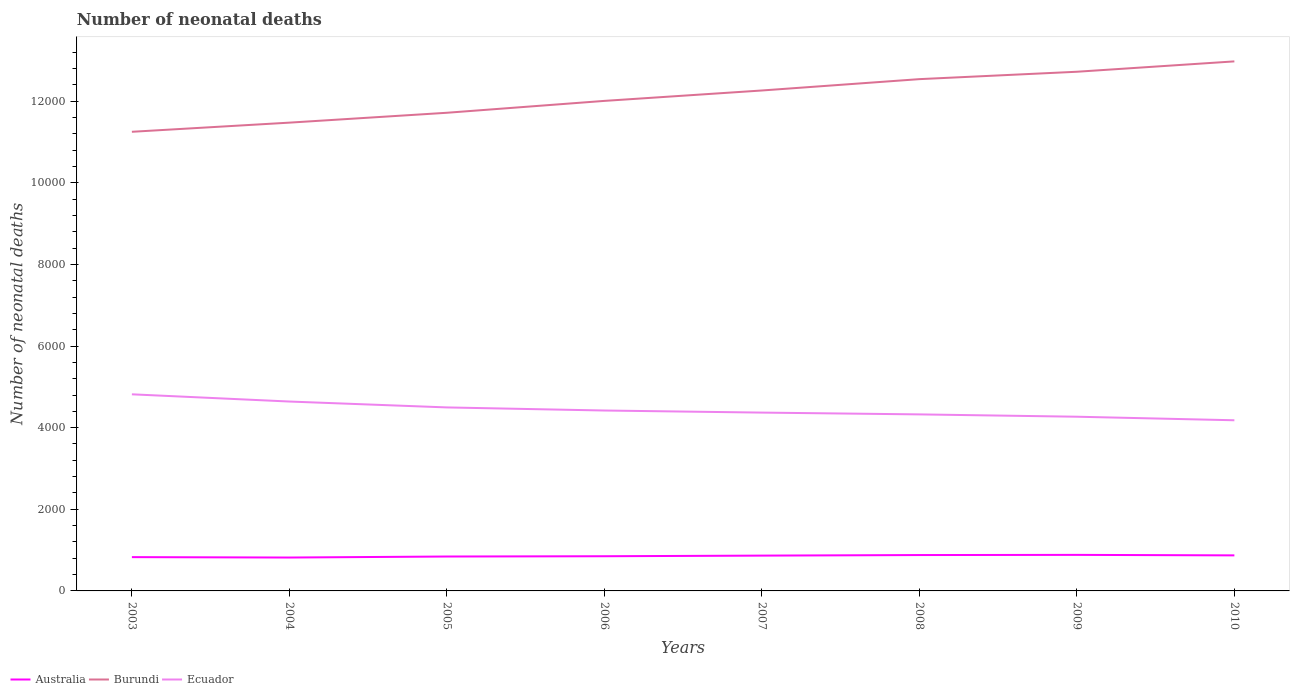How many different coloured lines are there?
Provide a short and direct response. 3. Across all years, what is the maximum number of neonatal deaths in in Ecuador?
Provide a succinct answer. 4181. In which year was the number of neonatal deaths in in Ecuador maximum?
Keep it short and to the point. 2010. What is the total number of neonatal deaths in in Ecuador in the graph?
Your answer should be very brief. 144. What is the difference between the highest and the second highest number of neonatal deaths in in Ecuador?
Give a very brief answer. 636. Does the graph contain any zero values?
Give a very brief answer. No. Does the graph contain grids?
Provide a succinct answer. No. Where does the legend appear in the graph?
Give a very brief answer. Bottom left. How many legend labels are there?
Give a very brief answer. 3. What is the title of the graph?
Ensure brevity in your answer.  Number of neonatal deaths. What is the label or title of the Y-axis?
Offer a terse response. Number of neonatal deaths. What is the Number of neonatal deaths of Australia in 2003?
Offer a very short reply. 828. What is the Number of neonatal deaths of Burundi in 2003?
Offer a very short reply. 1.12e+04. What is the Number of neonatal deaths of Ecuador in 2003?
Offer a terse response. 4817. What is the Number of neonatal deaths in Australia in 2004?
Your answer should be compact. 818. What is the Number of neonatal deaths in Burundi in 2004?
Your answer should be compact. 1.15e+04. What is the Number of neonatal deaths of Ecuador in 2004?
Provide a short and direct response. 4640. What is the Number of neonatal deaths in Australia in 2005?
Your answer should be very brief. 843. What is the Number of neonatal deaths in Burundi in 2005?
Provide a short and direct response. 1.17e+04. What is the Number of neonatal deaths in Ecuador in 2005?
Your response must be concise. 4496. What is the Number of neonatal deaths of Australia in 2006?
Offer a terse response. 850. What is the Number of neonatal deaths of Burundi in 2006?
Your response must be concise. 1.20e+04. What is the Number of neonatal deaths of Ecuador in 2006?
Offer a terse response. 4420. What is the Number of neonatal deaths of Australia in 2007?
Your answer should be very brief. 865. What is the Number of neonatal deaths of Burundi in 2007?
Provide a succinct answer. 1.23e+04. What is the Number of neonatal deaths in Ecuador in 2007?
Your answer should be very brief. 4369. What is the Number of neonatal deaths in Australia in 2008?
Offer a very short reply. 879. What is the Number of neonatal deaths of Burundi in 2008?
Offer a terse response. 1.25e+04. What is the Number of neonatal deaths of Ecuador in 2008?
Provide a succinct answer. 4325. What is the Number of neonatal deaths of Australia in 2009?
Offer a terse response. 883. What is the Number of neonatal deaths in Burundi in 2009?
Provide a succinct answer. 1.27e+04. What is the Number of neonatal deaths in Ecuador in 2009?
Your answer should be compact. 4268. What is the Number of neonatal deaths in Australia in 2010?
Provide a succinct answer. 871. What is the Number of neonatal deaths in Burundi in 2010?
Offer a very short reply. 1.30e+04. What is the Number of neonatal deaths in Ecuador in 2010?
Make the answer very short. 4181. Across all years, what is the maximum Number of neonatal deaths of Australia?
Ensure brevity in your answer.  883. Across all years, what is the maximum Number of neonatal deaths of Burundi?
Offer a terse response. 1.30e+04. Across all years, what is the maximum Number of neonatal deaths in Ecuador?
Give a very brief answer. 4817. Across all years, what is the minimum Number of neonatal deaths of Australia?
Offer a terse response. 818. Across all years, what is the minimum Number of neonatal deaths of Burundi?
Your answer should be very brief. 1.12e+04. Across all years, what is the minimum Number of neonatal deaths in Ecuador?
Your answer should be compact. 4181. What is the total Number of neonatal deaths in Australia in the graph?
Give a very brief answer. 6837. What is the total Number of neonatal deaths in Burundi in the graph?
Your response must be concise. 9.69e+04. What is the total Number of neonatal deaths in Ecuador in the graph?
Provide a short and direct response. 3.55e+04. What is the difference between the Number of neonatal deaths of Burundi in 2003 and that in 2004?
Your answer should be very brief. -224. What is the difference between the Number of neonatal deaths in Ecuador in 2003 and that in 2004?
Keep it short and to the point. 177. What is the difference between the Number of neonatal deaths of Burundi in 2003 and that in 2005?
Give a very brief answer. -466. What is the difference between the Number of neonatal deaths of Ecuador in 2003 and that in 2005?
Offer a very short reply. 321. What is the difference between the Number of neonatal deaths of Australia in 2003 and that in 2006?
Offer a very short reply. -22. What is the difference between the Number of neonatal deaths of Burundi in 2003 and that in 2006?
Provide a short and direct response. -757. What is the difference between the Number of neonatal deaths of Ecuador in 2003 and that in 2006?
Your answer should be very brief. 397. What is the difference between the Number of neonatal deaths of Australia in 2003 and that in 2007?
Make the answer very short. -37. What is the difference between the Number of neonatal deaths of Burundi in 2003 and that in 2007?
Ensure brevity in your answer.  -1012. What is the difference between the Number of neonatal deaths in Ecuador in 2003 and that in 2007?
Your answer should be compact. 448. What is the difference between the Number of neonatal deaths in Australia in 2003 and that in 2008?
Make the answer very short. -51. What is the difference between the Number of neonatal deaths in Burundi in 2003 and that in 2008?
Provide a succinct answer. -1290. What is the difference between the Number of neonatal deaths in Ecuador in 2003 and that in 2008?
Give a very brief answer. 492. What is the difference between the Number of neonatal deaths in Australia in 2003 and that in 2009?
Make the answer very short. -55. What is the difference between the Number of neonatal deaths in Burundi in 2003 and that in 2009?
Provide a succinct answer. -1471. What is the difference between the Number of neonatal deaths of Ecuador in 2003 and that in 2009?
Your answer should be very brief. 549. What is the difference between the Number of neonatal deaths of Australia in 2003 and that in 2010?
Your response must be concise. -43. What is the difference between the Number of neonatal deaths in Burundi in 2003 and that in 2010?
Make the answer very short. -1725. What is the difference between the Number of neonatal deaths in Ecuador in 2003 and that in 2010?
Ensure brevity in your answer.  636. What is the difference between the Number of neonatal deaths in Australia in 2004 and that in 2005?
Keep it short and to the point. -25. What is the difference between the Number of neonatal deaths in Burundi in 2004 and that in 2005?
Make the answer very short. -242. What is the difference between the Number of neonatal deaths of Ecuador in 2004 and that in 2005?
Provide a succinct answer. 144. What is the difference between the Number of neonatal deaths of Australia in 2004 and that in 2006?
Keep it short and to the point. -32. What is the difference between the Number of neonatal deaths in Burundi in 2004 and that in 2006?
Offer a terse response. -533. What is the difference between the Number of neonatal deaths in Ecuador in 2004 and that in 2006?
Keep it short and to the point. 220. What is the difference between the Number of neonatal deaths in Australia in 2004 and that in 2007?
Provide a short and direct response. -47. What is the difference between the Number of neonatal deaths of Burundi in 2004 and that in 2007?
Ensure brevity in your answer.  -788. What is the difference between the Number of neonatal deaths of Ecuador in 2004 and that in 2007?
Provide a short and direct response. 271. What is the difference between the Number of neonatal deaths in Australia in 2004 and that in 2008?
Ensure brevity in your answer.  -61. What is the difference between the Number of neonatal deaths in Burundi in 2004 and that in 2008?
Ensure brevity in your answer.  -1066. What is the difference between the Number of neonatal deaths in Ecuador in 2004 and that in 2008?
Your answer should be compact. 315. What is the difference between the Number of neonatal deaths in Australia in 2004 and that in 2009?
Ensure brevity in your answer.  -65. What is the difference between the Number of neonatal deaths of Burundi in 2004 and that in 2009?
Make the answer very short. -1247. What is the difference between the Number of neonatal deaths of Ecuador in 2004 and that in 2009?
Your answer should be compact. 372. What is the difference between the Number of neonatal deaths in Australia in 2004 and that in 2010?
Your answer should be compact. -53. What is the difference between the Number of neonatal deaths of Burundi in 2004 and that in 2010?
Ensure brevity in your answer.  -1501. What is the difference between the Number of neonatal deaths in Ecuador in 2004 and that in 2010?
Your answer should be very brief. 459. What is the difference between the Number of neonatal deaths in Australia in 2005 and that in 2006?
Your answer should be compact. -7. What is the difference between the Number of neonatal deaths in Burundi in 2005 and that in 2006?
Offer a terse response. -291. What is the difference between the Number of neonatal deaths of Burundi in 2005 and that in 2007?
Your answer should be compact. -546. What is the difference between the Number of neonatal deaths in Ecuador in 2005 and that in 2007?
Your answer should be very brief. 127. What is the difference between the Number of neonatal deaths of Australia in 2005 and that in 2008?
Your answer should be compact. -36. What is the difference between the Number of neonatal deaths of Burundi in 2005 and that in 2008?
Provide a short and direct response. -824. What is the difference between the Number of neonatal deaths in Ecuador in 2005 and that in 2008?
Provide a short and direct response. 171. What is the difference between the Number of neonatal deaths of Burundi in 2005 and that in 2009?
Give a very brief answer. -1005. What is the difference between the Number of neonatal deaths in Ecuador in 2005 and that in 2009?
Make the answer very short. 228. What is the difference between the Number of neonatal deaths of Australia in 2005 and that in 2010?
Offer a very short reply. -28. What is the difference between the Number of neonatal deaths in Burundi in 2005 and that in 2010?
Offer a very short reply. -1259. What is the difference between the Number of neonatal deaths of Ecuador in 2005 and that in 2010?
Your answer should be compact. 315. What is the difference between the Number of neonatal deaths of Australia in 2006 and that in 2007?
Make the answer very short. -15. What is the difference between the Number of neonatal deaths of Burundi in 2006 and that in 2007?
Your response must be concise. -255. What is the difference between the Number of neonatal deaths of Australia in 2006 and that in 2008?
Provide a short and direct response. -29. What is the difference between the Number of neonatal deaths in Burundi in 2006 and that in 2008?
Offer a very short reply. -533. What is the difference between the Number of neonatal deaths in Australia in 2006 and that in 2009?
Offer a terse response. -33. What is the difference between the Number of neonatal deaths in Burundi in 2006 and that in 2009?
Your answer should be compact. -714. What is the difference between the Number of neonatal deaths in Ecuador in 2006 and that in 2009?
Offer a terse response. 152. What is the difference between the Number of neonatal deaths of Australia in 2006 and that in 2010?
Your answer should be compact. -21. What is the difference between the Number of neonatal deaths in Burundi in 2006 and that in 2010?
Your response must be concise. -968. What is the difference between the Number of neonatal deaths of Ecuador in 2006 and that in 2010?
Make the answer very short. 239. What is the difference between the Number of neonatal deaths of Australia in 2007 and that in 2008?
Your answer should be compact. -14. What is the difference between the Number of neonatal deaths of Burundi in 2007 and that in 2008?
Your answer should be compact. -278. What is the difference between the Number of neonatal deaths in Ecuador in 2007 and that in 2008?
Your answer should be very brief. 44. What is the difference between the Number of neonatal deaths of Australia in 2007 and that in 2009?
Give a very brief answer. -18. What is the difference between the Number of neonatal deaths of Burundi in 2007 and that in 2009?
Keep it short and to the point. -459. What is the difference between the Number of neonatal deaths in Ecuador in 2007 and that in 2009?
Make the answer very short. 101. What is the difference between the Number of neonatal deaths in Australia in 2007 and that in 2010?
Provide a short and direct response. -6. What is the difference between the Number of neonatal deaths of Burundi in 2007 and that in 2010?
Your answer should be compact. -713. What is the difference between the Number of neonatal deaths of Ecuador in 2007 and that in 2010?
Your response must be concise. 188. What is the difference between the Number of neonatal deaths of Australia in 2008 and that in 2009?
Offer a very short reply. -4. What is the difference between the Number of neonatal deaths of Burundi in 2008 and that in 2009?
Ensure brevity in your answer.  -181. What is the difference between the Number of neonatal deaths in Ecuador in 2008 and that in 2009?
Ensure brevity in your answer.  57. What is the difference between the Number of neonatal deaths of Australia in 2008 and that in 2010?
Give a very brief answer. 8. What is the difference between the Number of neonatal deaths of Burundi in 2008 and that in 2010?
Keep it short and to the point. -435. What is the difference between the Number of neonatal deaths of Ecuador in 2008 and that in 2010?
Give a very brief answer. 144. What is the difference between the Number of neonatal deaths of Australia in 2009 and that in 2010?
Offer a terse response. 12. What is the difference between the Number of neonatal deaths in Burundi in 2009 and that in 2010?
Make the answer very short. -254. What is the difference between the Number of neonatal deaths in Ecuador in 2009 and that in 2010?
Ensure brevity in your answer.  87. What is the difference between the Number of neonatal deaths of Australia in 2003 and the Number of neonatal deaths of Burundi in 2004?
Give a very brief answer. -1.06e+04. What is the difference between the Number of neonatal deaths in Australia in 2003 and the Number of neonatal deaths in Ecuador in 2004?
Keep it short and to the point. -3812. What is the difference between the Number of neonatal deaths of Burundi in 2003 and the Number of neonatal deaths of Ecuador in 2004?
Keep it short and to the point. 6609. What is the difference between the Number of neonatal deaths in Australia in 2003 and the Number of neonatal deaths in Burundi in 2005?
Keep it short and to the point. -1.09e+04. What is the difference between the Number of neonatal deaths in Australia in 2003 and the Number of neonatal deaths in Ecuador in 2005?
Your response must be concise. -3668. What is the difference between the Number of neonatal deaths in Burundi in 2003 and the Number of neonatal deaths in Ecuador in 2005?
Keep it short and to the point. 6753. What is the difference between the Number of neonatal deaths in Australia in 2003 and the Number of neonatal deaths in Burundi in 2006?
Make the answer very short. -1.12e+04. What is the difference between the Number of neonatal deaths in Australia in 2003 and the Number of neonatal deaths in Ecuador in 2006?
Your response must be concise. -3592. What is the difference between the Number of neonatal deaths of Burundi in 2003 and the Number of neonatal deaths of Ecuador in 2006?
Your response must be concise. 6829. What is the difference between the Number of neonatal deaths in Australia in 2003 and the Number of neonatal deaths in Burundi in 2007?
Provide a succinct answer. -1.14e+04. What is the difference between the Number of neonatal deaths in Australia in 2003 and the Number of neonatal deaths in Ecuador in 2007?
Your answer should be very brief. -3541. What is the difference between the Number of neonatal deaths in Burundi in 2003 and the Number of neonatal deaths in Ecuador in 2007?
Make the answer very short. 6880. What is the difference between the Number of neonatal deaths in Australia in 2003 and the Number of neonatal deaths in Burundi in 2008?
Offer a terse response. -1.17e+04. What is the difference between the Number of neonatal deaths in Australia in 2003 and the Number of neonatal deaths in Ecuador in 2008?
Keep it short and to the point. -3497. What is the difference between the Number of neonatal deaths in Burundi in 2003 and the Number of neonatal deaths in Ecuador in 2008?
Offer a very short reply. 6924. What is the difference between the Number of neonatal deaths in Australia in 2003 and the Number of neonatal deaths in Burundi in 2009?
Offer a very short reply. -1.19e+04. What is the difference between the Number of neonatal deaths in Australia in 2003 and the Number of neonatal deaths in Ecuador in 2009?
Offer a very short reply. -3440. What is the difference between the Number of neonatal deaths in Burundi in 2003 and the Number of neonatal deaths in Ecuador in 2009?
Provide a short and direct response. 6981. What is the difference between the Number of neonatal deaths of Australia in 2003 and the Number of neonatal deaths of Burundi in 2010?
Your answer should be very brief. -1.21e+04. What is the difference between the Number of neonatal deaths in Australia in 2003 and the Number of neonatal deaths in Ecuador in 2010?
Provide a succinct answer. -3353. What is the difference between the Number of neonatal deaths in Burundi in 2003 and the Number of neonatal deaths in Ecuador in 2010?
Your response must be concise. 7068. What is the difference between the Number of neonatal deaths of Australia in 2004 and the Number of neonatal deaths of Burundi in 2005?
Make the answer very short. -1.09e+04. What is the difference between the Number of neonatal deaths of Australia in 2004 and the Number of neonatal deaths of Ecuador in 2005?
Provide a succinct answer. -3678. What is the difference between the Number of neonatal deaths of Burundi in 2004 and the Number of neonatal deaths of Ecuador in 2005?
Your response must be concise. 6977. What is the difference between the Number of neonatal deaths of Australia in 2004 and the Number of neonatal deaths of Burundi in 2006?
Your response must be concise. -1.12e+04. What is the difference between the Number of neonatal deaths of Australia in 2004 and the Number of neonatal deaths of Ecuador in 2006?
Keep it short and to the point. -3602. What is the difference between the Number of neonatal deaths in Burundi in 2004 and the Number of neonatal deaths in Ecuador in 2006?
Provide a short and direct response. 7053. What is the difference between the Number of neonatal deaths in Australia in 2004 and the Number of neonatal deaths in Burundi in 2007?
Ensure brevity in your answer.  -1.14e+04. What is the difference between the Number of neonatal deaths of Australia in 2004 and the Number of neonatal deaths of Ecuador in 2007?
Make the answer very short. -3551. What is the difference between the Number of neonatal deaths in Burundi in 2004 and the Number of neonatal deaths in Ecuador in 2007?
Your answer should be compact. 7104. What is the difference between the Number of neonatal deaths in Australia in 2004 and the Number of neonatal deaths in Burundi in 2008?
Keep it short and to the point. -1.17e+04. What is the difference between the Number of neonatal deaths in Australia in 2004 and the Number of neonatal deaths in Ecuador in 2008?
Your response must be concise. -3507. What is the difference between the Number of neonatal deaths of Burundi in 2004 and the Number of neonatal deaths of Ecuador in 2008?
Your response must be concise. 7148. What is the difference between the Number of neonatal deaths of Australia in 2004 and the Number of neonatal deaths of Burundi in 2009?
Ensure brevity in your answer.  -1.19e+04. What is the difference between the Number of neonatal deaths of Australia in 2004 and the Number of neonatal deaths of Ecuador in 2009?
Give a very brief answer. -3450. What is the difference between the Number of neonatal deaths of Burundi in 2004 and the Number of neonatal deaths of Ecuador in 2009?
Your answer should be very brief. 7205. What is the difference between the Number of neonatal deaths of Australia in 2004 and the Number of neonatal deaths of Burundi in 2010?
Make the answer very short. -1.22e+04. What is the difference between the Number of neonatal deaths in Australia in 2004 and the Number of neonatal deaths in Ecuador in 2010?
Your answer should be very brief. -3363. What is the difference between the Number of neonatal deaths in Burundi in 2004 and the Number of neonatal deaths in Ecuador in 2010?
Ensure brevity in your answer.  7292. What is the difference between the Number of neonatal deaths of Australia in 2005 and the Number of neonatal deaths of Burundi in 2006?
Offer a terse response. -1.12e+04. What is the difference between the Number of neonatal deaths of Australia in 2005 and the Number of neonatal deaths of Ecuador in 2006?
Give a very brief answer. -3577. What is the difference between the Number of neonatal deaths of Burundi in 2005 and the Number of neonatal deaths of Ecuador in 2006?
Your response must be concise. 7295. What is the difference between the Number of neonatal deaths of Australia in 2005 and the Number of neonatal deaths of Burundi in 2007?
Give a very brief answer. -1.14e+04. What is the difference between the Number of neonatal deaths of Australia in 2005 and the Number of neonatal deaths of Ecuador in 2007?
Keep it short and to the point. -3526. What is the difference between the Number of neonatal deaths of Burundi in 2005 and the Number of neonatal deaths of Ecuador in 2007?
Your response must be concise. 7346. What is the difference between the Number of neonatal deaths of Australia in 2005 and the Number of neonatal deaths of Burundi in 2008?
Make the answer very short. -1.17e+04. What is the difference between the Number of neonatal deaths of Australia in 2005 and the Number of neonatal deaths of Ecuador in 2008?
Offer a very short reply. -3482. What is the difference between the Number of neonatal deaths in Burundi in 2005 and the Number of neonatal deaths in Ecuador in 2008?
Keep it short and to the point. 7390. What is the difference between the Number of neonatal deaths in Australia in 2005 and the Number of neonatal deaths in Burundi in 2009?
Ensure brevity in your answer.  -1.19e+04. What is the difference between the Number of neonatal deaths in Australia in 2005 and the Number of neonatal deaths in Ecuador in 2009?
Your answer should be very brief. -3425. What is the difference between the Number of neonatal deaths in Burundi in 2005 and the Number of neonatal deaths in Ecuador in 2009?
Keep it short and to the point. 7447. What is the difference between the Number of neonatal deaths in Australia in 2005 and the Number of neonatal deaths in Burundi in 2010?
Provide a short and direct response. -1.21e+04. What is the difference between the Number of neonatal deaths in Australia in 2005 and the Number of neonatal deaths in Ecuador in 2010?
Provide a succinct answer. -3338. What is the difference between the Number of neonatal deaths of Burundi in 2005 and the Number of neonatal deaths of Ecuador in 2010?
Give a very brief answer. 7534. What is the difference between the Number of neonatal deaths of Australia in 2006 and the Number of neonatal deaths of Burundi in 2007?
Your answer should be very brief. -1.14e+04. What is the difference between the Number of neonatal deaths of Australia in 2006 and the Number of neonatal deaths of Ecuador in 2007?
Your answer should be compact. -3519. What is the difference between the Number of neonatal deaths of Burundi in 2006 and the Number of neonatal deaths of Ecuador in 2007?
Keep it short and to the point. 7637. What is the difference between the Number of neonatal deaths in Australia in 2006 and the Number of neonatal deaths in Burundi in 2008?
Offer a very short reply. -1.17e+04. What is the difference between the Number of neonatal deaths in Australia in 2006 and the Number of neonatal deaths in Ecuador in 2008?
Offer a terse response. -3475. What is the difference between the Number of neonatal deaths in Burundi in 2006 and the Number of neonatal deaths in Ecuador in 2008?
Offer a very short reply. 7681. What is the difference between the Number of neonatal deaths of Australia in 2006 and the Number of neonatal deaths of Burundi in 2009?
Offer a very short reply. -1.19e+04. What is the difference between the Number of neonatal deaths in Australia in 2006 and the Number of neonatal deaths in Ecuador in 2009?
Ensure brevity in your answer.  -3418. What is the difference between the Number of neonatal deaths in Burundi in 2006 and the Number of neonatal deaths in Ecuador in 2009?
Your answer should be very brief. 7738. What is the difference between the Number of neonatal deaths in Australia in 2006 and the Number of neonatal deaths in Burundi in 2010?
Offer a terse response. -1.21e+04. What is the difference between the Number of neonatal deaths of Australia in 2006 and the Number of neonatal deaths of Ecuador in 2010?
Provide a succinct answer. -3331. What is the difference between the Number of neonatal deaths of Burundi in 2006 and the Number of neonatal deaths of Ecuador in 2010?
Provide a succinct answer. 7825. What is the difference between the Number of neonatal deaths of Australia in 2007 and the Number of neonatal deaths of Burundi in 2008?
Make the answer very short. -1.17e+04. What is the difference between the Number of neonatal deaths of Australia in 2007 and the Number of neonatal deaths of Ecuador in 2008?
Keep it short and to the point. -3460. What is the difference between the Number of neonatal deaths in Burundi in 2007 and the Number of neonatal deaths in Ecuador in 2008?
Give a very brief answer. 7936. What is the difference between the Number of neonatal deaths in Australia in 2007 and the Number of neonatal deaths in Burundi in 2009?
Your answer should be compact. -1.19e+04. What is the difference between the Number of neonatal deaths of Australia in 2007 and the Number of neonatal deaths of Ecuador in 2009?
Provide a succinct answer. -3403. What is the difference between the Number of neonatal deaths of Burundi in 2007 and the Number of neonatal deaths of Ecuador in 2009?
Make the answer very short. 7993. What is the difference between the Number of neonatal deaths of Australia in 2007 and the Number of neonatal deaths of Burundi in 2010?
Make the answer very short. -1.21e+04. What is the difference between the Number of neonatal deaths of Australia in 2007 and the Number of neonatal deaths of Ecuador in 2010?
Make the answer very short. -3316. What is the difference between the Number of neonatal deaths in Burundi in 2007 and the Number of neonatal deaths in Ecuador in 2010?
Ensure brevity in your answer.  8080. What is the difference between the Number of neonatal deaths of Australia in 2008 and the Number of neonatal deaths of Burundi in 2009?
Give a very brief answer. -1.18e+04. What is the difference between the Number of neonatal deaths in Australia in 2008 and the Number of neonatal deaths in Ecuador in 2009?
Offer a very short reply. -3389. What is the difference between the Number of neonatal deaths of Burundi in 2008 and the Number of neonatal deaths of Ecuador in 2009?
Provide a succinct answer. 8271. What is the difference between the Number of neonatal deaths in Australia in 2008 and the Number of neonatal deaths in Burundi in 2010?
Your response must be concise. -1.21e+04. What is the difference between the Number of neonatal deaths of Australia in 2008 and the Number of neonatal deaths of Ecuador in 2010?
Your answer should be very brief. -3302. What is the difference between the Number of neonatal deaths of Burundi in 2008 and the Number of neonatal deaths of Ecuador in 2010?
Keep it short and to the point. 8358. What is the difference between the Number of neonatal deaths of Australia in 2009 and the Number of neonatal deaths of Burundi in 2010?
Keep it short and to the point. -1.21e+04. What is the difference between the Number of neonatal deaths in Australia in 2009 and the Number of neonatal deaths in Ecuador in 2010?
Your answer should be compact. -3298. What is the difference between the Number of neonatal deaths in Burundi in 2009 and the Number of neonatal deaths in Ecuador in 2010?
Keep it short and to the point. 8539. What is the average Number of neonatal deaths of Australia per year?
Provide a succinct answer. 854.62. What is the average Number of neonatal deaths of Burundi per year?
Your response must be concise. 1.21e+04. What is the average Number of neonatal deaths of Ecuador per year?
Offer a very short reply. 4439.5. In the year 2003, what is the difference between the Number of neonatal deaths in Australia and Number of neonatal deaths in Burundi?
Give a very brief answer. -1.04e+04. In the year 2003, what is the difference between the Number of neonatal deaths in Australia and Number of neonatal deaths in Ecuador?
Your answer should be compact. -3989. In the year 2003, what is the difference between the Number of neonatal deaths in Burundi and Number of neonatal deaths in Ecuador?
Provide a succinct answer. 6432. In the year 2004, what is the difference between the Number of neonatal deaths in Australia and Number of neonatal deaths in Burundi?
Your response must be concise. -1.07e+04. In the year 2004, what is the difference between the Number of neonatal deaths in Australia and Number of neonatal deaths in Ecuador?
Ensure brevity in your answer.  -3822. In the year 2004, what is the difference between the Number of neonatal deaths in Burundi and Number of neonatal deaths in Ecuador?
Offer a terse response. 6833. In the year 2005, what is the difference between the Number of neonatal deaths in Australia and Number of neonatal deaths in Burundi?
Your response must be concise. -1.09e+04. In the year 2005, what is the difference between the Number of neonatal deaths in Australia and Number of neonatal deaths in Ecuador?
Your response must be concise. -3653. In the year 2005, what is the difference between the Number of neonatal deaths of Burundi and Number of neonatal deaths of Ecuador?
Offer a very short reply. 7219. In the year 2006, what is the difference between the Number of neonatal deaths of Australia and Number of neonatal deaths of Burundi?
Provide a succinct answer. -1.12e+04. In the year 2006, what is the difference between the Number of neonatal deaths in Australia and Number of neonatal deaths in Ecuador?
Your response must be concise. -3570. In the year 2006, what is the difference between the Number of neonatal deaths of Burundi and Number of neonatal deaths of Ecuador?
Give a very brief answer. 7586. In the year 2007, what is the difference between the Number of neonatal deaths of Australia and Number of neonatal deaths of Burundi?
Keep it short and to the point. -1.14e+04. In the year 2007, what is the difference between the Number of neonatal deaths in Australia and Number of neonatal deaths in Ecuador?
Your response must be concise. -3504. In the year 2007, what is the difference between the Number of neonatal deaths of Burundi and Number of neonatal deaths of Ecuador?
Offer a very short reply. 7892. In the year 2008, what is the difference between the Number of neonatal deaths in Australia and Number of neonatal deaths in Burundi?
Provide a short and direct response. -1.17e+04. In the year 2008, what is the difference between the Number of neonatal deaths in Australia and Number of neonatal deaths in Ecuador?
Your answer should be very brief. -3446. In the year 2008, what is the difference between the Number of neonatal deaths of Burundi and Number of neonatal deaths of Ecuador?
Your answer should be very brief. 8214. In the year 2009, what is the difference between the Number of neonatal deaths in Australia and Number of neonatal deaths in Burundi?
Give a very brief answer. -1.18e+04. In the year 2009, what is the difference between the Number of neonatal deaths of Australia and Number of neonatal deaths of Ecuador?
Your answer should be compact. -3385. In the year 2009, what is the difference between the Number of neonatal deaths in Burundi and Number of neonatal deaths in Ecuador?
Ensure brevity in your answer.  8452. In the year 2010, what is the difference between the Number of neonatal deaths of Australia and Number of neonatal deaths of Burundi?
Your answer should be very brief. -1.21e+04. In the year 2010, what is the difference between the Number of neonatal deaths of Australia and Number of neonatal deaths of Ecuador?
Ensure brevity in your answer.  -3310. In the year 2010, what is the difference between the Number of neonatal deaths in Burundi and Number of neonatal deaths in Ecuador?
Ensure brevity in your answer.  8793. What is the ratio of the Number of neonatal deaths of Australia in 2003 to that in 2004?
Keep it short and to the point. 1.01. What is the ratio of the Number of neonatal deaths in Burundi in 2003 to that in 2004?
Your answer should be compact. 0.98. What is the ratio of the Number of neonatal deaths of Ecuador in 2003 to that in 2004?
Offer a terse response. 1.04. What is the ratio of the Number of neonatal deaths of Australia in 2003 to that in 2005?
Your response must be concise. 0.98. What is the ratio of the Number of neonatal deaths of Burundi in 2003 to that in 2005?
Provide a succinct answer. 0.96. What is the ratio of the Number of neonatal deaths in Ecuador in 2003 to that in 2005?
Offer a very short reply. 1.07. What is the ratio of the Number of neonatal deaths in Australia in 2003 to that in 2006?
Make the answer very short. 0.97. What is the ratio of the Number of neonatal deaths in Burundi in 2003 to that in 2006?
Provide a short and direct response. 0.94. What is the ratio of the Number of neonatal deaths of Ecuador in 2003 to that in 2006?
Your answer should be compact. 1.09. What is the ratio of the Number of neonatal deaths in Australia in 2003 to that in 2007?
Provide a short and direct response. 0.96. What is the ratio of the Number of neonatal deaths in Burundi in 2003 to that in 2007?
Your answer should be compact. 0.92. What is the ratio of the Number of neonatal deaths in Ecuador in 2003 to that in 2007?
Ensure brevity in your answer.  1.1. What is the ratio of the Number of neonatal deaths of Australia in 2003 to that in 2008?
Ensure brevity in your answer.  0.94. What is the ratio of the Number of neonatal deaths in Burundi in 2003 to that in 2008?
Offer a terse response. 0.9. What is the ratio of the Number of neonatal deaths of Ecuador in 2003 to that in 2008?
Make the answer very short. 1.11. What is the ratio of the Number of neonatal deaths of Australia in 2003 to that in 2009?
Make the answer very short. 0.94. What is the ratio of the Number of neonatal deaths of Burundi in 2003 to that in 2009?
Offer a very short reply. 0.88. What is the ratio of the Number of neonatal deaths of Ecuador in 2003 to that in 2009?
Ensure brevity in your answer.  1.13. What is the ratio of the Number of neonatal deaths in Australia in 2003 to that in 2010?
Your answer should be compact. 0.95. What is the ratio of the Number of neonatal deaths of Burundi in 2003 to that in 2010?
Ensure brevity in your answer.  0.87. What is the ratio of the Number of neonatal deaths in Ecuador in 2003 to that in 2010?
Your answer should be very brief. 1.15. What is the ratio of the Number of neonatal deaths in Australia in 2004 to that in 2005?
Offer a terse response. 0.97. What is the ratio of the Number of neonatal deaths in Burundi in 2004 to that in 2005?
Your response must be concise. 0.98. What is the ratio of the Number of neonatal deaths in Ecuador in 2004 to that in 2005?
Provide a succinct answer. 1.03. What is the ratio of the Number of neonatal deaths in Australia in 2004 to that in 2006?
Make the answer very short. 0.96. What is the ratio of the Number of neonatal deaths in Burundi in 2004 to that in 2006?
Provide a short and direct response. 0.96. What is the ratio of the Number of neonatal deaths in Ecuador in 2004 to that in 2006?
Keep it short and to the point. 1.05. What is the ratio of the Number of neonatal deaths of Australia in 2004 to that in 2007?
Offer a very short reply. 0.95. What is the ratio of the Number of neonatal deaths of Burundi in 2004 to that in 2007?
Your response must be concise. 0.94. What is the ratio of the Number of neonatal deaths in Ecuador in 2004 to that in 2007?
Offer a terse response. 1.06. What is the ratio of the Number of neonatal deaths of Australia in 2004 to that in 2008?
Keep it short and to the point. 0.93. What is the ratio of the Number of neonatal deaths in Burundi in 2004 to that in 2008?
Offer a very short reply. 0.92. What is the ratio of the Number of neonatal deaths of Ecuador in 2004 to that in 2008?
Ensure brevity in your answer.  1.07. What is the ratio of the Number of neonatal deaths in Australia in 2004 to that in 2009?
Give a very brief answer. 0.93. What is the ratio of the Number of neonatal deaths of Burundi in 2004 to that in 2009?
Make the answer very short. 0.9. What is the ratio of the Number of neonatal deaths of Ecuador in 2004 to that in 2009?
Offer a terse response. 1.09. What is the ratio of the Number of neonatal deaths in Australia in 2004 to that in 2010?
Provide a short and direct response. 0.94. What is the ratio of the Number of neonatal deaths of Burundi in 2004 to that in 2010?
Make the answer very short. 0.88. What is the ratio of the Number of neonatal deaths in Ecuador in 2004 to that in 2010?
Provide a short and direct response. 1.11. What is the ratio of the Number of neonatal deaths of Australia in 2005 to that in 2006?
Offer a very short reply. 0.99. What is the ratio of the Number of neonatal deaths in Burundi in 2005 to that in 2006?
Offer a terse response. 0.98. What is the ratio of the Number of neonatal deaths of Ecuador in 2005 to that in 2006?
Make the answer very short. 1.02. What is the ratio of the Number of neonatal deaths of Australia in 2005 to that in 2007?
Provide a succinct answer. 0.97. What is the ratio of the Number of neonatal deaths in Burundi in 2005 to that in 2007?
Provide a short and direct response. 0.96. What is the ratio of the Number of neonatal deaths in Ecuador in 2005 to that in 2007?
Your response must be concise. 1.03. What is the ratio of the Number of neonatal deaths in Australia in 2005 to that in 2008?
Provide a succinct answer. 0.96. What is the ratio of the Number of neonatal deaths in Burundi in 2005 to that in 2008?
Your answer should be compact. 0.93. What is the ratio of the Number of neonatal deaths of Ecuador in 2005 to that in 2008?
Give a very brief answer. 1.04. What is the ratio of the Number of neonatal deaths of Australia in 2005 to that in 2009?
Make the answer very short. 0.95. What is the ratio of the Number of neonatal deaths of Burundi in 2005 to that in 2009?
Keep it short and to the point. 0.92. What is the ratio of the Number of neonatal deaths of Ecuador in 2005 to that in 2009?
Provide a succinct answer. 1.05. What is the ratio of the Number of neonatal deaths of Australia in 2005 to that in 2010?
Give a very brief answer. 0.97. What is the ratio of the Number of neonatal deaths of Burundi in 2005 to that in 2010?
Your answer should be compact. 0.9. What is the ratio of the Number of neonatal deaths of Ecuador in 2005 to that in 2010?
Your response must be concise. 1.08. What is the ratio of the Number of neonatal deaths in Australia in 2006 to that in 2007?
Keep it short and to the point. 0.98. What is the ratio of the Number of neonatal deaths of Burundi in 2006 to that in 2007?
Keep it short and to the point. 0.98. What is the ratio of the Number of neonatal deaths of Ecuador in 2006 to that in 2007?
Ensure brevity in your answer.  1.01. What is the ratio of the Number of neonatal deaths of Burundi in 2006 to that in 2008?
Give a very brief answer. 0.96. What is the ratio of the Number of neonatal deaths in Ecuador in 2006 to that in 2008?
Your answer should be very brief. 1.02. What is the ratio of the Number of neonatal deaths in Australia in 2006 to that in 2009?
Provide a succinct answer. 0.96. What is the ratio of the Number of neonatal deaths of Burundi in 2006 to that in 2009?
Your response must be concise. 0.94. What is the ratio of the Number of neonatal deaths in Ecuador in 2006 to that in 2009?
Provide a short and direct response. 1.04. What is the ratio of the Number of neonatal deaths of Australia in 2006 to that in 2010?
Your answer should be compact. 0.98. What is the ratio of the Number of neonatal deaths in Burundi in 2006 to that in 2010?
Offer a very short reply. 0.93. What is the ratio of the Number of neonatal deaths in Ecuador in 2006 to that in 2010?
Offer a terse response. 1.06. What is the ratio of the Number of neonatal deaths in Australia in 2007 to that in 2008?
Your answer should be compact. 0.98. What is the ratio of the Number of neonatal deaths in Burundi in 2007 to that in 2008?
Offer a terse response. 0.98. What is the ratio of the Number of neonatal deaths in Ecuador in 2007 to that in 2008?
Offer a very short reply. 1.01. What is the ratio of the Number of neonatal deaths of Australia in 2007 to that in 2009?
Your answer should be compact. 0.98. What is the ratio of the Number of neonatal deaths in Burundi in 2007 to that in 2009?
Offer a very short reply. 0.96. What is the ratio of the Number of neonatal deaths in Ecuador in 2007 to that in 2009?
Make the answer very short. 1.02. What is the ratio of the Number of neonatal deaths of Australia in 2007 to that in 2010?
Provide a succinct answer. 0.99. What is the ratio of the Number of neonatal deaths of Burundi in 2007 to that in 2010?
Provide a short and direct response. 0.94. What is the ratio of the Number of neonatal deaths of Ecuador in 2007 to that in 2010?
Provide a succinct answer. 1.04. What is the ratio of the Number of neonatal deaths in Burundi in 2008 to that in 2009?
Provide a succinct answer. 0.99. What is the ratio of the Number of neonatal deaths in Ecuador in 2008 to that in 2009?
Your answer should be very brief. 1.01. What is the ratio of the Number of neonatal deaths of Australia in 2008 to that in 2010?
Provide a succinct answer. 1.01. What is the ratio of the Number of neonatal deaths of Burundi in 2008 to that in 2010?
Provide a succinct answer. 0.97. What is the ratio of the Number of neonatal deaths of Ecuador in 2008 to that in 2010?
Your answer should be compact. 1.03. What is the ratio of the Number of neonatal deaths in Australia in 2009 to that in 2010?
Provide a succinct answer. 1.01. What is the ratio of the Number of neonatal deaths of Burundi in 2009 to that in 2010?
Keep it short and to the point. 0.98. What is the ratio of the Number of neonatal deaths in Ecuador in 2009 to that in 2010?
Provide a short and direct response. 1.02. What is the difference between the highest and the second highest Number of neonatal deaths in Burundi?
Ensure brevity in your answer.  254. What is the difference between the highest and the second highest Number of neonatal deaths in Ecuador?
Offer a terse response. 177. What is the difference between the highest and the lowest Number of neonatal deaths of Burundi?
Keep it short and to the point. 1725. What is the difference between the highest and the lowest Number of neonatal deaths in Ecuador?
Keep it short and to the point. 636. 